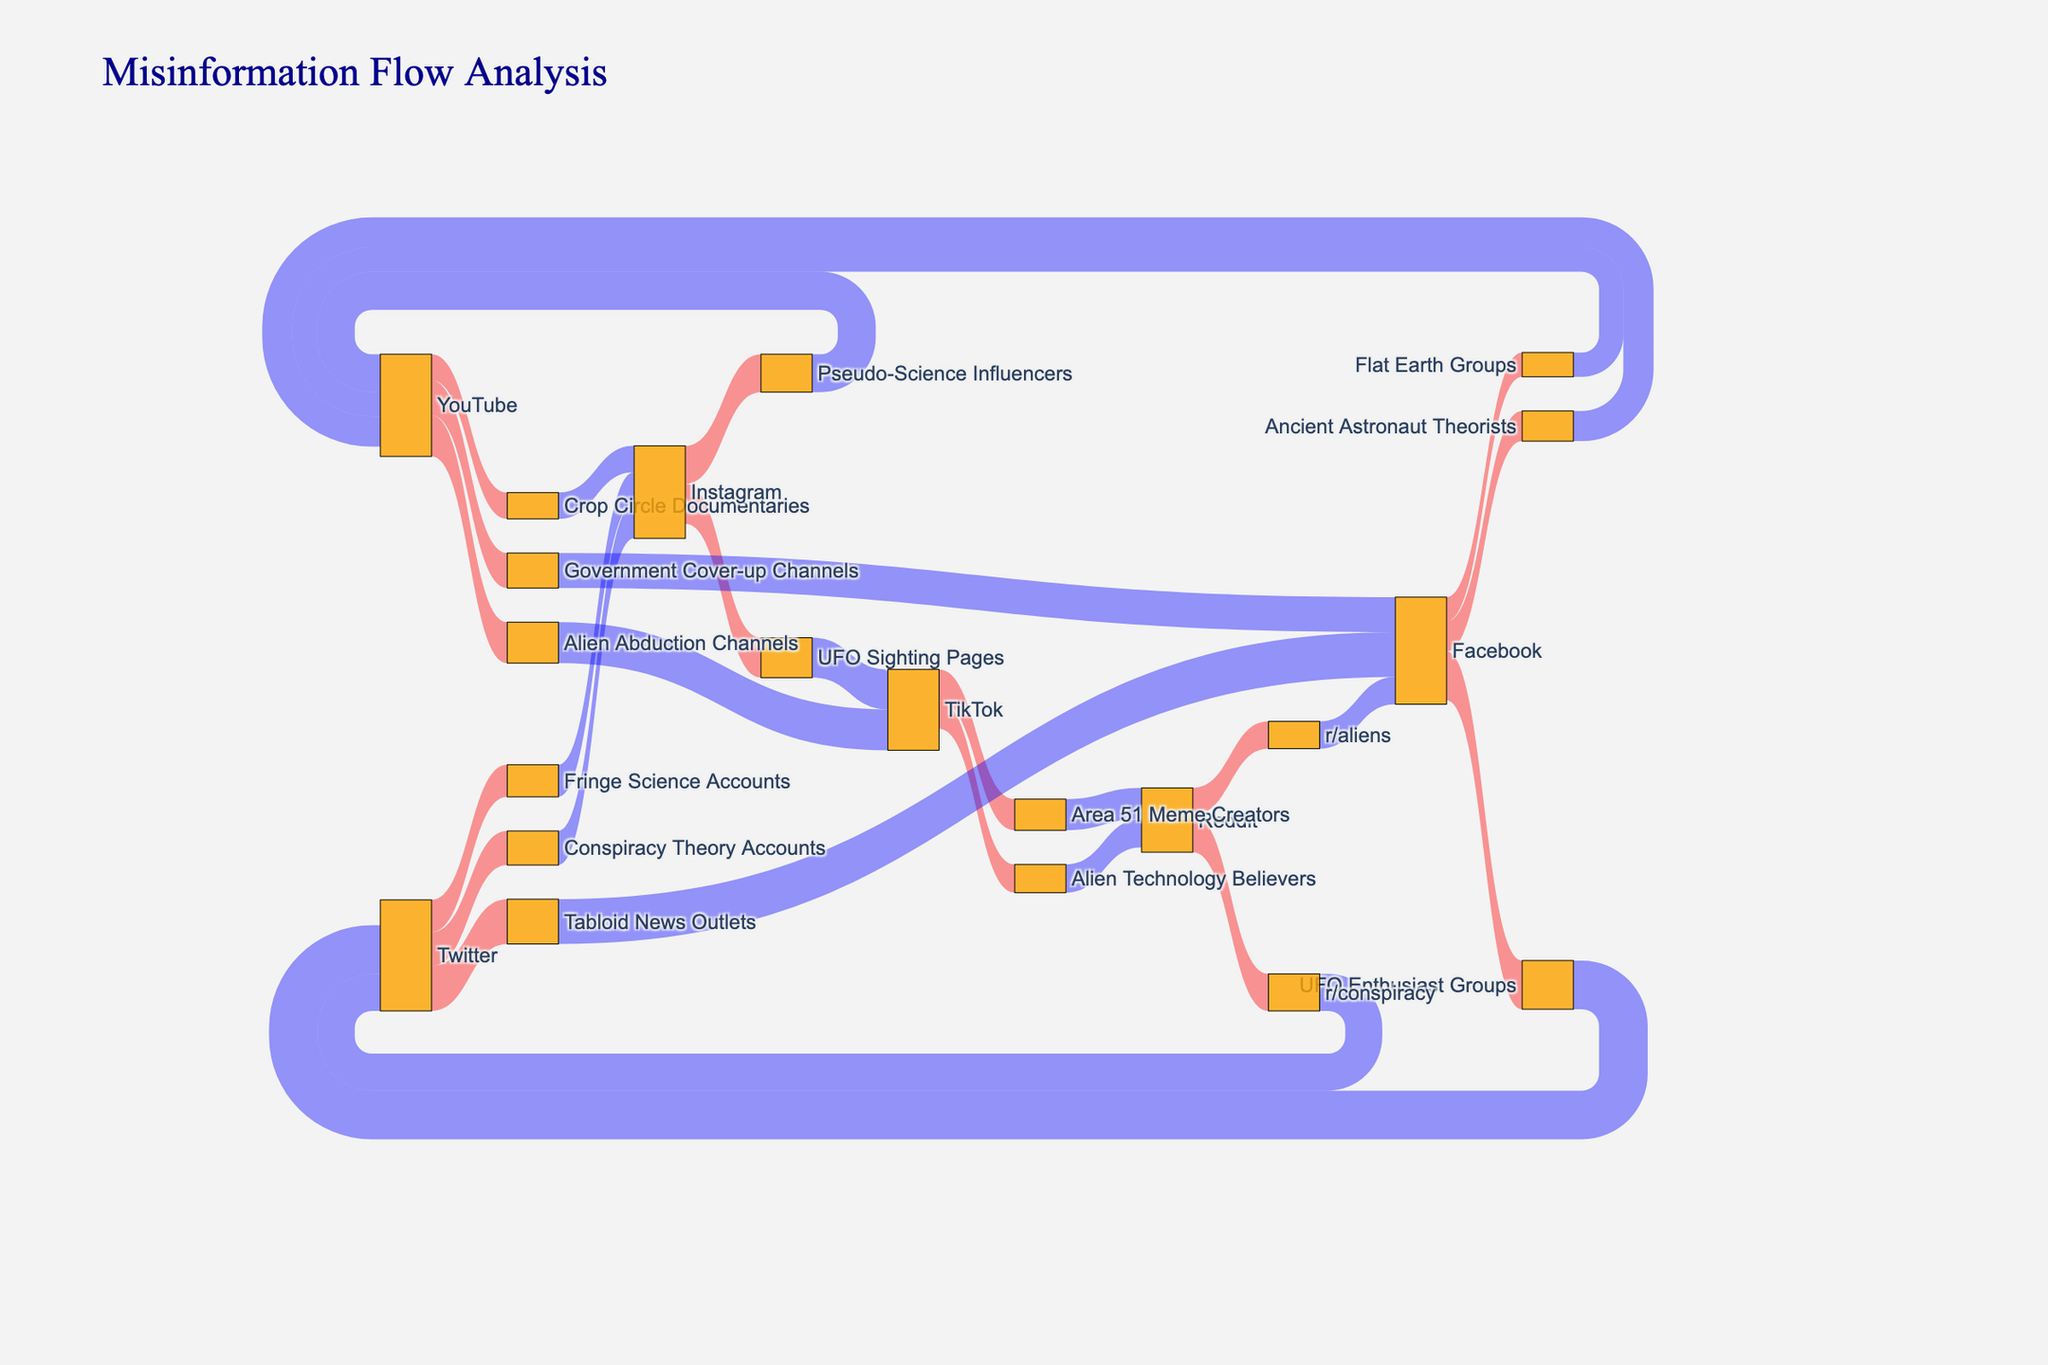What's the title of the figure? The title is usually placed at the top center of the diagram. Here, it reads "Misinformation Flow Analysis" indicating the main theme of the Sankey diagram.
Answer: Misinformation Flow Analysis How many user groups are listed as intermediaries? To find the number of intermediaries, list all distinct entries in the intermediary column: UFO Enthusiast Groups, Conspiracy Theory Accounts, Alien Abduction Channels, r/aliens, Pseudo-Science Influencers, Area 51 Meme Creators, Tabloid News Outlets, Ancient Astronaut Theorists, Crop Circle Documentaries, r/conspiracy, UFO Sighting Pages, Alien Technology Believers, Flat Earth Groups, Fringe Science Accounts, and Government Cover-up Channels. Count them to get 15.
Answer: 15 Which intermediary has the highest total incoming flow? Add up the values flowing into each intermediary: "UFO Enthusiast Groups" has 5000, "Conspiracy Theory Accounts" has 3500, "Alien Abduction Channels" has 4200, "r/aliens" has 2800, "Pseudo-Science Influencers" has 3900, "Area 51 Meme Creators" has 3200, "Tabloid News Outlets" has 4600, "Ancient Astronaut Theorists" has 3100, "Crop Circle Documentaries" has 2700, "r/conspiracy" has 3800, "UFO Sighting Pages" has 4100, "Alien Technology Believers" has 2900, "Flat Earth Groups" has 2500, "Fringe Science Accounts" has 3300, and "Government Cover-up Channels" has 3600. The intermediary with the highest total incoming flow is "UFO Enthusiast Groups" with 5000.
Answer: UFO Enthusiast Groups Which target platform receives the most misinformation flow from Facebook? Identify all entries where Facebook is the source and sum up their values to their respective targets: Facebook to Twitter (5000) and Facebook to YouTube (2500 + 3100 + 3600). The total flow to Twitter from Facebook is 5000, and YouTube from Facebook is 9200. The target platform that receives the most misinformation flow from Facebook is YouTube.
Answer: YouTube What is the total flow from YouTube as a source? Identify all entries where YouTube is the source: YouTube to TikTok (4200), YouTube to Facebook (3600), YouTube to Instagram (2700), and YouTube to YouTube (3900). Sum these values: 4200 + 3600 + 2700 + 3900 = 14400. The total flow from YouTube as a source is 14400.
Answer: 14400 Which intermediary has the lowest total incoming flow? Add the values flowing into each intermediary and compare: "Flat Earth Groups" has 2500, being the lowest among intermediaries.
Answer: Flat Earth Groups Which target has more misinformation flow, Twitter or Instagram? Sum up flows to each target: Twitter has 5000 (from Facebook) + 3800 (from Reddit) = 8800, Instagram has 3300 (from Twitter) + 2700 (from YouTube) = 6000. Twitter has more flow than Instagram.
Answer: Twitter Which category has more sources, intermediaries or targets? Count the distinct elements in each category: Intermediaries have 15 unique entries, targets also have unique entries matching the intermediaries. Therefore, both have the same number.
Answer: Equal 